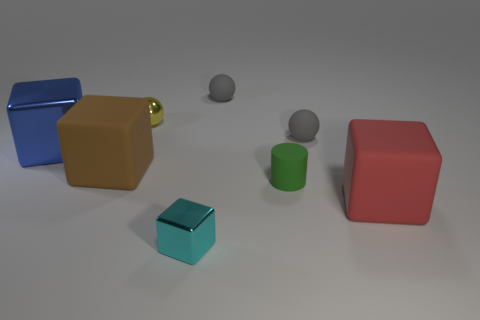Subtract all blue metallic blocks. How many blocks are left? 3 Add 2 big green rubber things. How many objects exist? 10 Subtract all gray spheres. How many spheres are left? 1 Subtract 2 balls. How many balls are left? 1 Subtract all cylinders. How many objects are left? 7 Subtract all blue cylinders. How many blue cubes are left? 1 Subtract all gray metallic balls. Subtract all rubber blocks. How many objects are left? 6 Add 1 metal things. How many metal things are left? 4 Add 6 small cyan shiny blocks. How many small cyan shiny blocks exist? 7 Subtract 1 yellow balls. How many objects are left? 7 